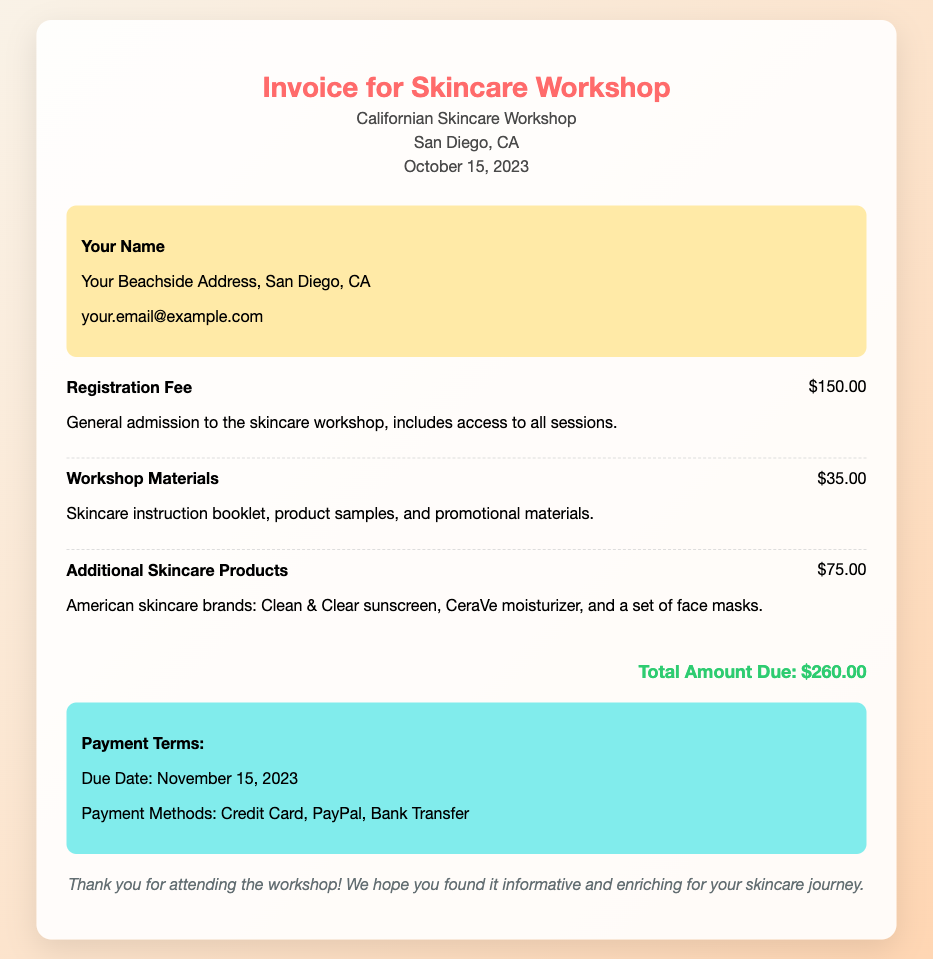What is the date of the workshop? The date of the workshop is mentioned in the header section of the document as October 15, 2023.
Answer: October 15, 2023 What is the total amount due? The total amount due is stated clearly at the bottom of the invoice as $260.00.
Answer: $260.00 What are the payment methods listed? The document specifies the payment methods in the payment terms section, including Credit Card, PayPal, and Bank Transfer.
Answer: Credit Card, PayPal, Bank Transfer How much is the registration fee? The registration fee is broken down in the invoice and is listed as $150.00.
Answer: $150.00 What product samples are included in the workshop materials? The workshop materials section mentions the inclusion of a skincare instruction booklet, product samples, and promotional materials.
Answer: Skincare instruction booklet, product samples, and promotional materials How much did the additional skincare products cost? The invoice outlines the cost of additional skincare products as $75.00.
Answer: $75.00 What is the due date for payment? The due date for payment is specifically mentioned in the payment terms section as November 15, 2023.
Answer: November 15, 2023 What is the location of the workshop? The workshop location is provided in the header part of the invoice as San Diego, CA.
Answer: San Diego, CA What message is included in the notes section? The notes section contains a thank-you message for attending the workshop, which expresses hope that the workshop was informative and enriching.
Answer: Thank you for attending the workshop! We hope you found it informative and enriching for your skincare journey 